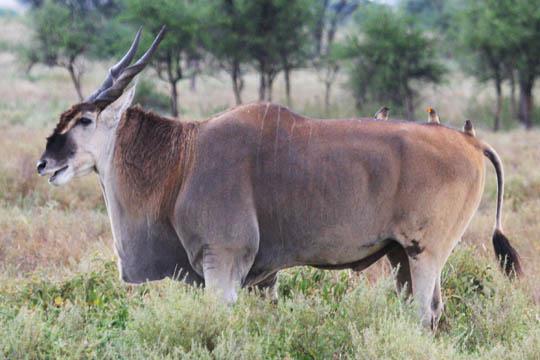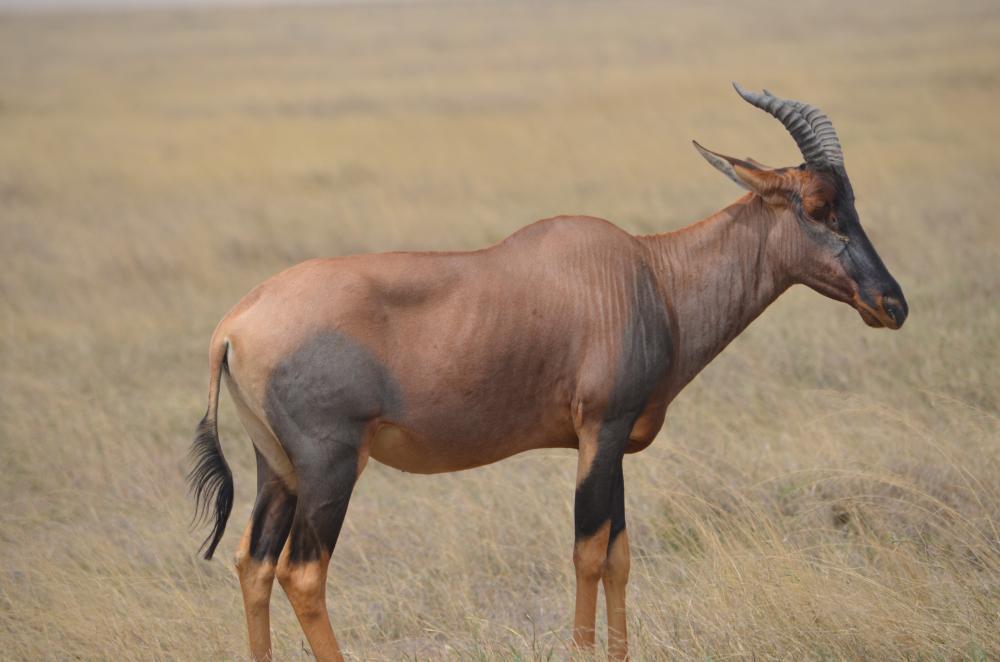The first image is the image on the left, the second image is the image on the right. Given the left and right images, does the statement "The left and right image contains a total of three elk." hold true? Answer yes or no. No. The first image is the image on the left, the second image is the image on the right. Assess this claim about the two images: "One image contains exactly twice as many hooved animals in the foreground as the other image.". Correct or not? Answer yes or no. No. 